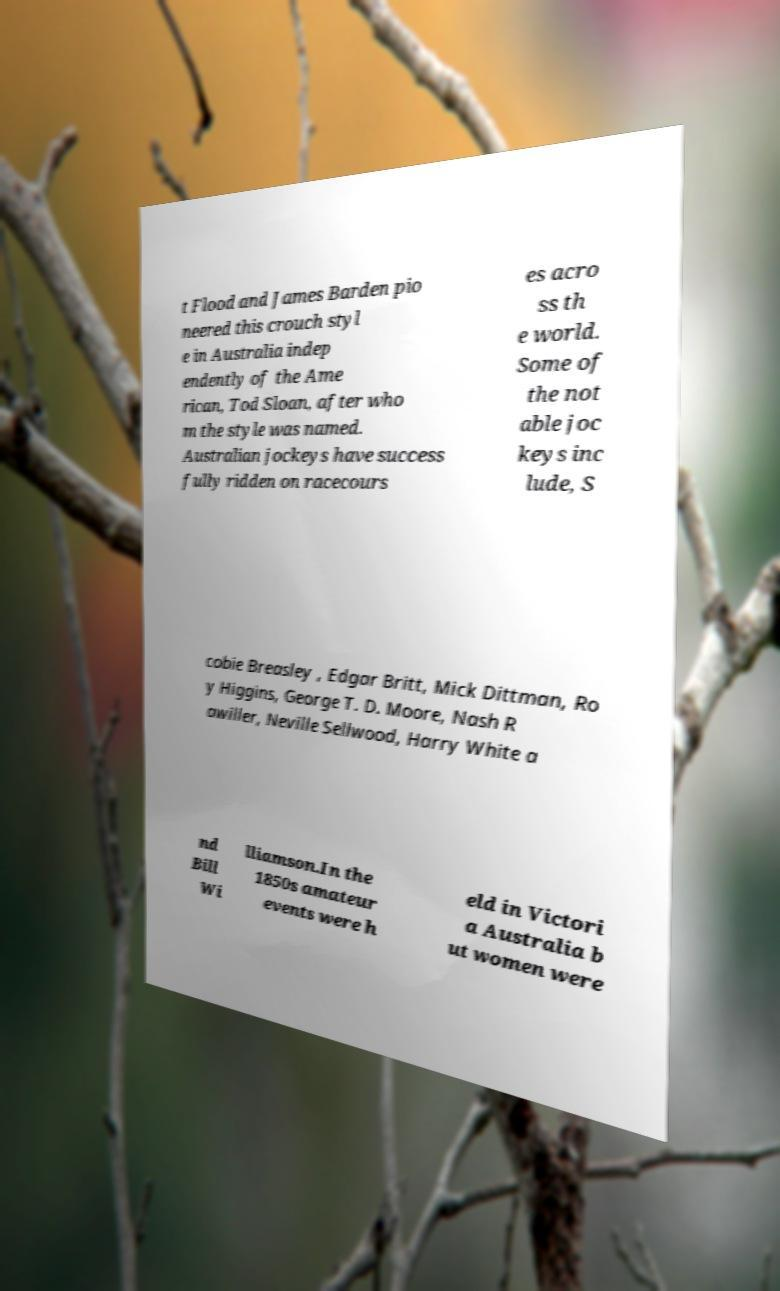I need the written content from this picture converted into text. Can you do that? t Flood and James Barden pio neered this crouch styl e in Australia indep endently of the Ame rican, Tod Sloan, after who m the style was named. Australian jockeys have success fully ridden on racecours es acro ss th e world. Some of the not able joc keys inc lude, S cobie Breasley , Edgar Britt, Mick Dittman, Ro y Higgins, George T. D. Moore, Nash R awiller, Neville Sellwood, Harry White a nd Bill Wi lliamson.In the 1850s amateur events were h eld in Victori a Australia b ut women were 